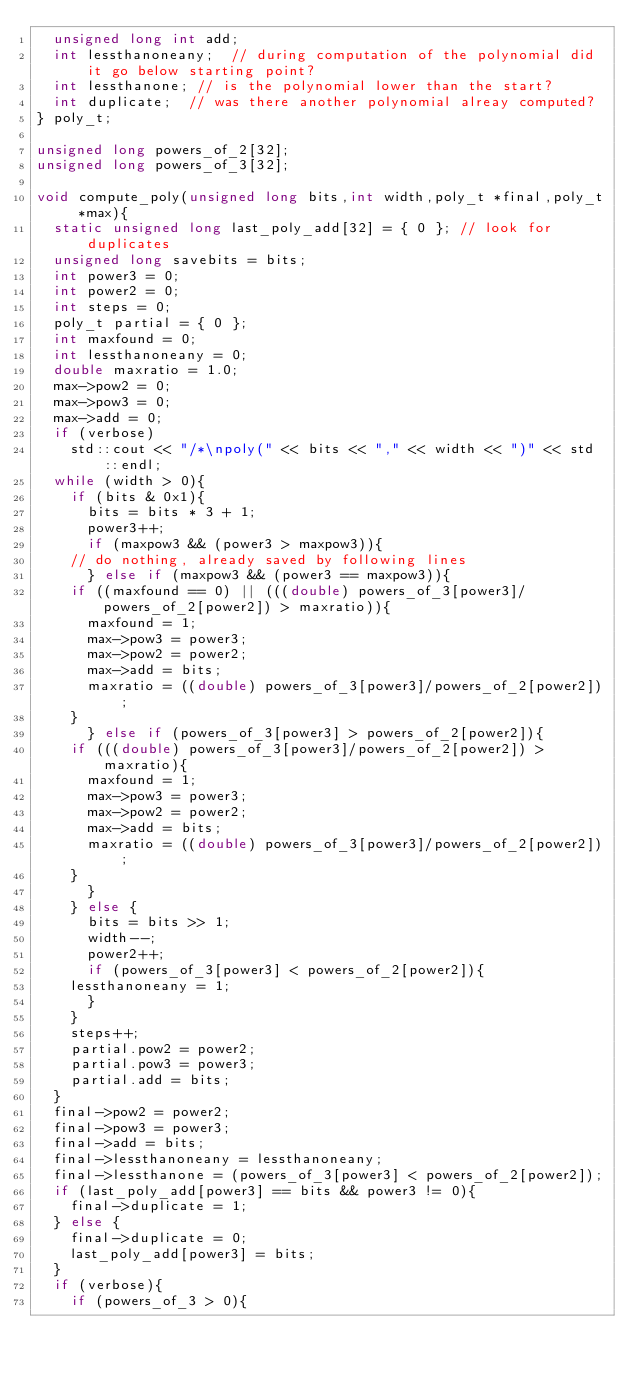<code> <loc_0><loc_0><loc_500><loc_500><_C++_>  unsigned long int add;
  int lessthanoneany;  // during computation of the polynomial did it go below starting point?
  int lessthanone; // is the polynomial lower than the start?
  int duplicate;  // was there another polynomial alreay computed?
} poly_t;

unsigned long powers_of_2[32];
unsigned long powers_of_3[32];

void compute_poly(unsigned long bits,int width,poly_t *final,poly_t *max){
  static unsigned long last_poly_add[32] = { 0 }; // look for duplicates
  unsigned long savebits = bits;
  int power3 = 0;
  int power2 = 0;
  int steps = 0;
  poly_t partial = { 0 };
  int maxfound = 0;
  int lessthanoneany = 0;
  double maxratio = 1.0;
  max->pow2 = 0;
  max->pow3 = 0;
  max->add = 0;
  if (verbose)
    std::cout << "/*\npoly(" << bits << "," << width << ")" << std::endl;
  while (width > 0){
    if (bits & 0x1){
      bits = bits * 3 + 1;
      power3++;
      if (maxpow3 && (power3 > maxpow3)){
	// do nothing, already saved by following lines
      } else if (maxpow3 && (power3 == maxpow3)){
	if ((maxfound == 0) || (((double) powers_of_3[power3]/powers_of_2[power2]) > maxratio)){
	  maxfound = 1;
	  max->pow3 = power3;
	  max->pow2 = power2;
	  max->add = bits;
	  maxratio = ((double) powers_of_3[power3]/powers_of_2[power2]);	  
	}
      } else if (powers_of_3[power3] > powers_of_2[power2]){
	if (((double) powers_of_3[power3]/powers_of_2[power2]) > maxratio){
	  maxfound = 1;
	  max->pow3 = power3;
	  max->pow2 = power2;
	  max->add = bits;
	  maxratio = ((double) powers_of_3[power3]/powers_of_2[power2]);
	}
      }
    } else {
      bits = bits >> 1;
      width--;
      power2++;
      if (powers_of_3[power3] < powers_of_2[power2]){
	lessthanoneany = 1;
      }
    }
    steps++;
    partial.pow2 = power2;
    partial.pow3 = power3;
    partial.add = bits;
  }
  final->pow2 = power2;
  final->pow3 = power3;
  final->add = bits;
  final->lessthanoneany = lessthanoneany;
  final->lessthanone = (powers_of_3[power3] < powers_of_2[power2]);
  if (last_poly_add[power3] == bits && power3 != 0){
    final->duplicate = 1;
  } else {
    final->duplicate = 0;
    last_poly_add[power3] = bits;
  }
  if (verbose){
    if (powers_of_3 > 0){</code> 